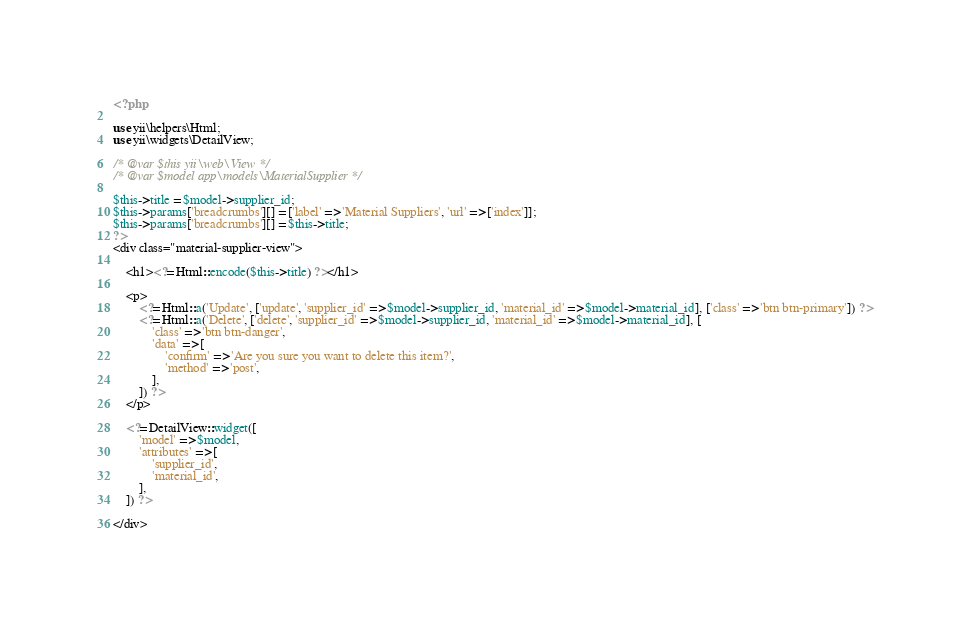Convert code to text. <code><loc_0><loc_0><loc_500><loc_500><_PHP_><?php

use yii\helpers\Html;
use yii\widgets\DetailView;

/* @var $this yii\web\View */
/* @var $model app\models\MaterialSupplier */

$this->title = $model->supplier_id;
$this->params['breadcrumbs'][] = ['label' => 'Material Suppliers', 'url' => ['index']];
$this->params['breadcrumbs'][] = $this->title;
?>
<div class="material-supplier-view">

    <h1><?= Html::encode($this->title) ?></h1>

    <p>
        <?= Html::a('Update', ['update', 'supplier_id' => $model->supplier_id, 'material_id' => $model->material_id], ['class' => 'btn btn-primary']) ?>
        <?= Html::a('Delete', ['delete', 'supplier_id' => $model->supplier_id, 'material_id' => $model->material_id], [
            'class' => 'btn btn-danger',
            'data' => [
                'confirm' => 'Are you sure you want to delete this item?',
                'method' => 'post',
            ],
        ]) ?>
    </p>

    <?= DetailView::widget([
        'model' => $model,
        'attributes' => [
            'supplier_id',
            'material_id',
        ],
    ]) ?>

</div>
</code> 